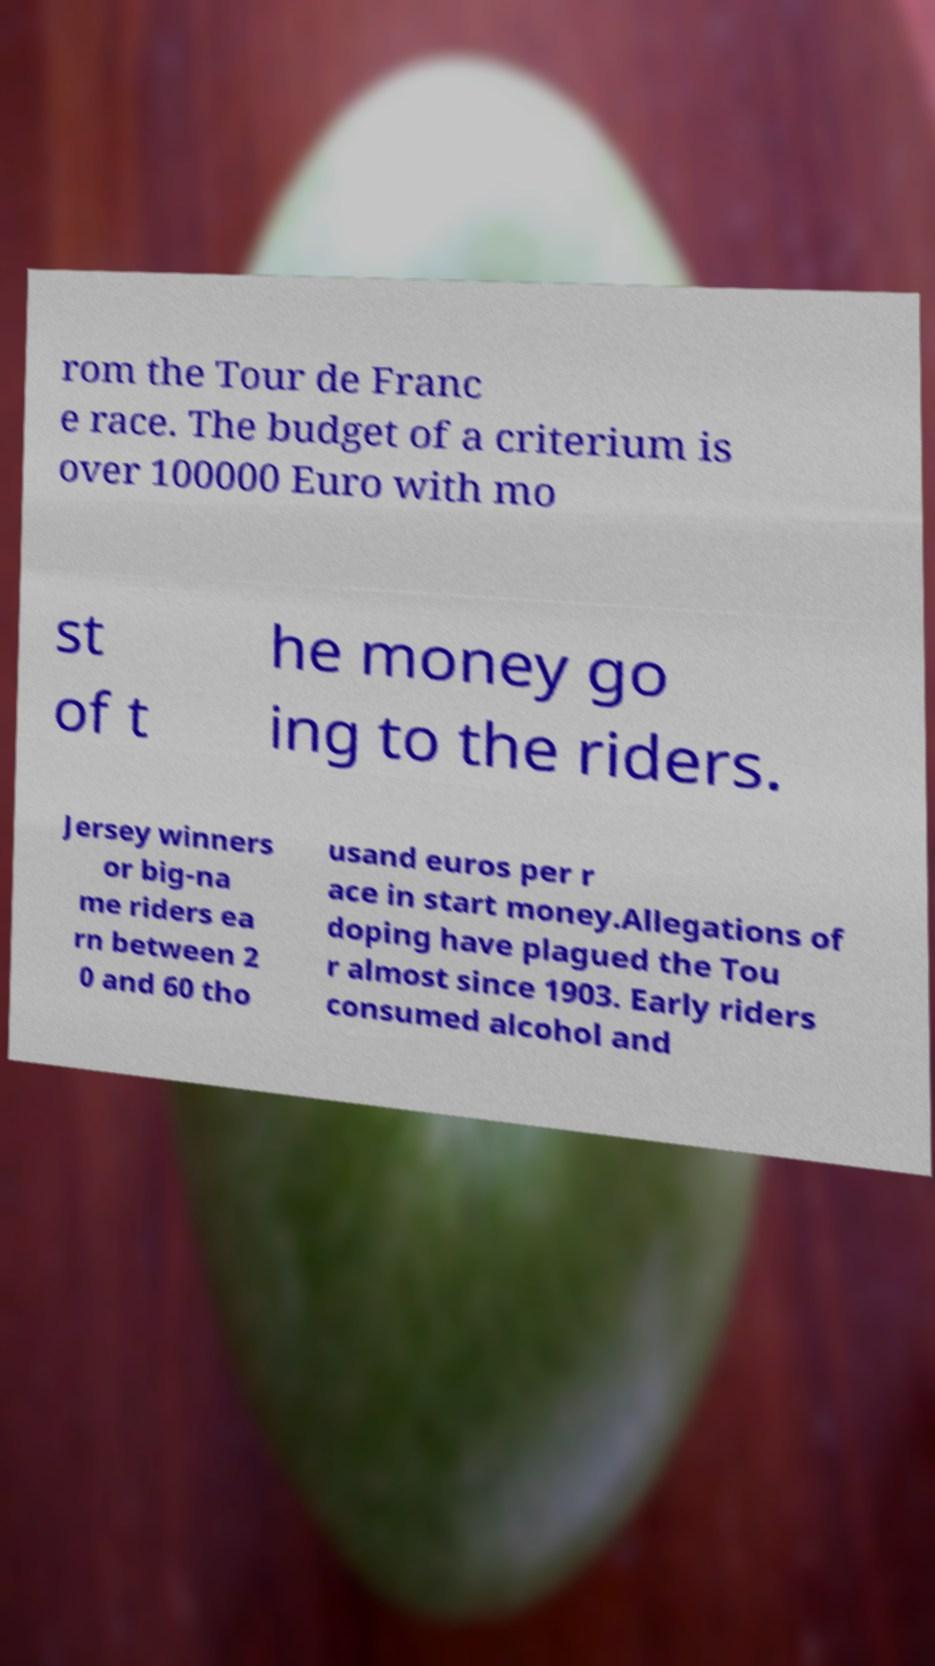What messages or text are displayed in this image? I need them in a readable, typed format. rom the Tour de Franc e race. The budget of a criterium is over 100000 Euro with mo st of t he money go ing to the riders. Jersey winners or big-na me riders ea rn between 2 0 and 60 tho usand euros per r ace in start money.Allegations of doping have plagued the Tou r almost since 1903. Early riders consumed alcohol and 